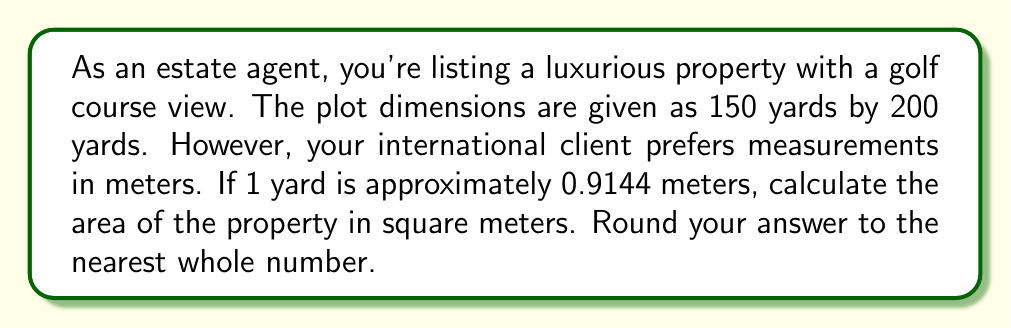Could you help me with this problem? Let's approach this step-by-step:

1) First, we need to convert the dimensions from yards to meters:

   Length: $150 \text{ yards} \times 0.9144 \text{ m/yard} = 137.16 \text{ m}$
   Width: $200 \text{ yards} \times 0.9144 \text{ m/yard} = 182.88 \text{ m}$

2) Now that we have the dimensions in meters, we can calculate the area:

   $$\text{Area} = \text{Length} \times \text{Width}$$
   $$\text{Area} = 137.16 \text{ m} \times 182.88 \text{ m}$$

3) Let's multiply these numbers:

   $$\text{Area} = 25,083.4208 \text{ m}^2$$

4) The question asks to round to the nearest whole number:

   $25,083.4208$ rounds to $25,083 \text{ m}^2$

Thus, the area of the property is approximately 25,083 square meters.
Answer: $25,083 \text{ m}^2$ 